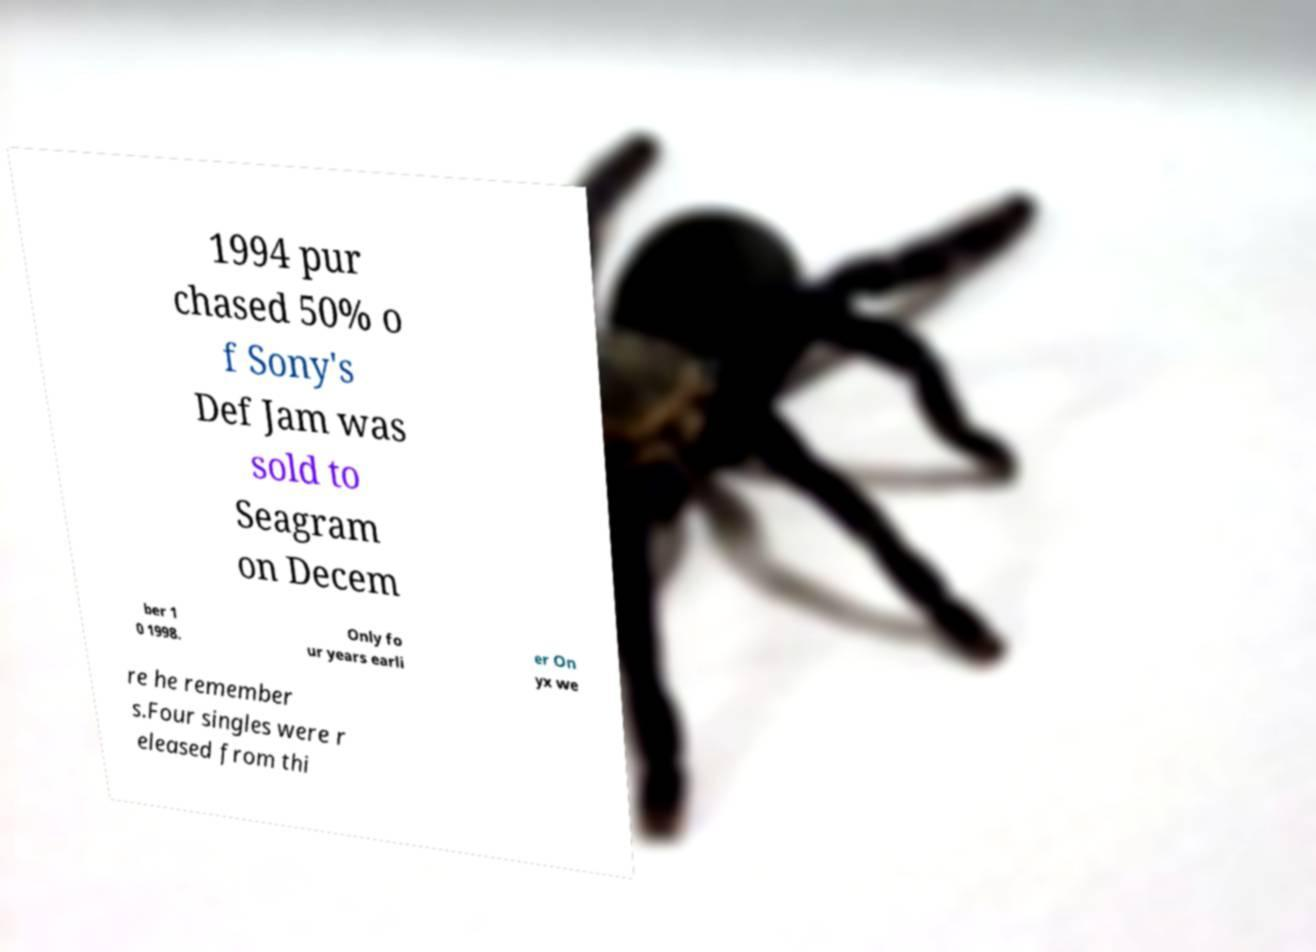What messages or text are displayed in this image? I need them in a readable, typed format. 1994 pur chased 50% o f Sony's Def Jam was sold to Seagram on Decem ber 1 0 1998. Only fo ur years earli er On yx we re he remember s.Four singles were r eleased from thi 